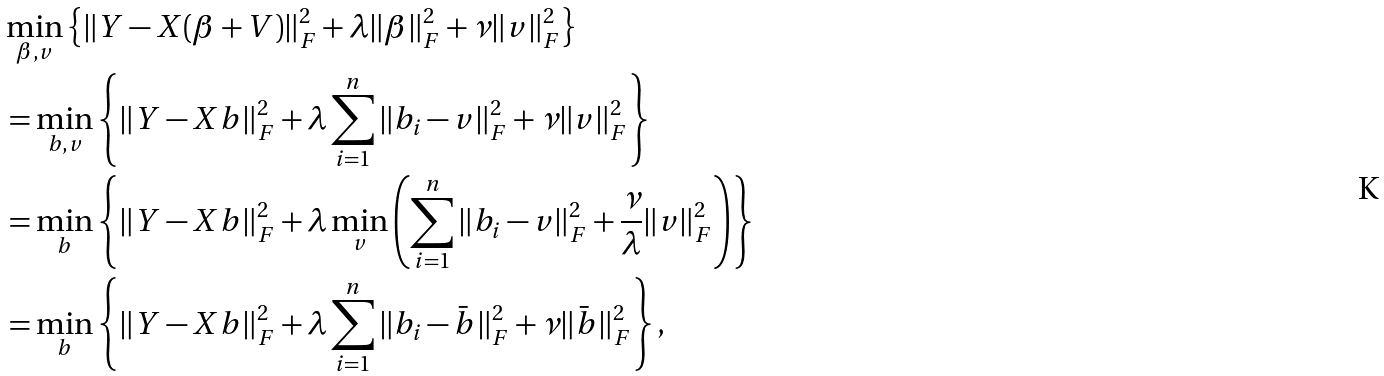<formula> <loc_0><loc_0><loc_500><loc_500>& \min _ { \beta , v } \left \{ \| Y - X ( \beta + V ) \| _ { F } ^ { 2 } + \lambda \| \beta \| ^ { 2 } _ { F } + \nu \| v \| ^ { 2 } _ { F } \right \} \\ & = \min _ { b , v } \left \{ \| Y - X b \| _ { F } ^ { 2 } + \lambda \sum _ { i = 1 } ^ { n } \| b _ { i } - v \| ^ { 2 } _ { F } + \nu \| v \| ^ { 2 } _ { F } \right \} \\ & = \min _ { b } \left \{ \| Y - X b \| _ { F } ^ { 2 } + \lambda \min _ { v } \left ( \sum _ { i = 1 } ^ { n } \| b _ { i } - v \| ^ { 2 } _ { F } + \frac { \nu } { \lambda } \| v \| ^ { 2 } _ { F } \right ) \right \} \\ & = \min _ { b } \left \{ \| Y - X b \| _ { F } ^ { 2 } + \lambda \sum _ { i = 1 } ^ { n } \| b _ { i } - \bar { b } \| ^ { 2 } _ { F } + \nu \| \bar { b } \| ^ { 2 } _ { F } \right \} ,</formula> 